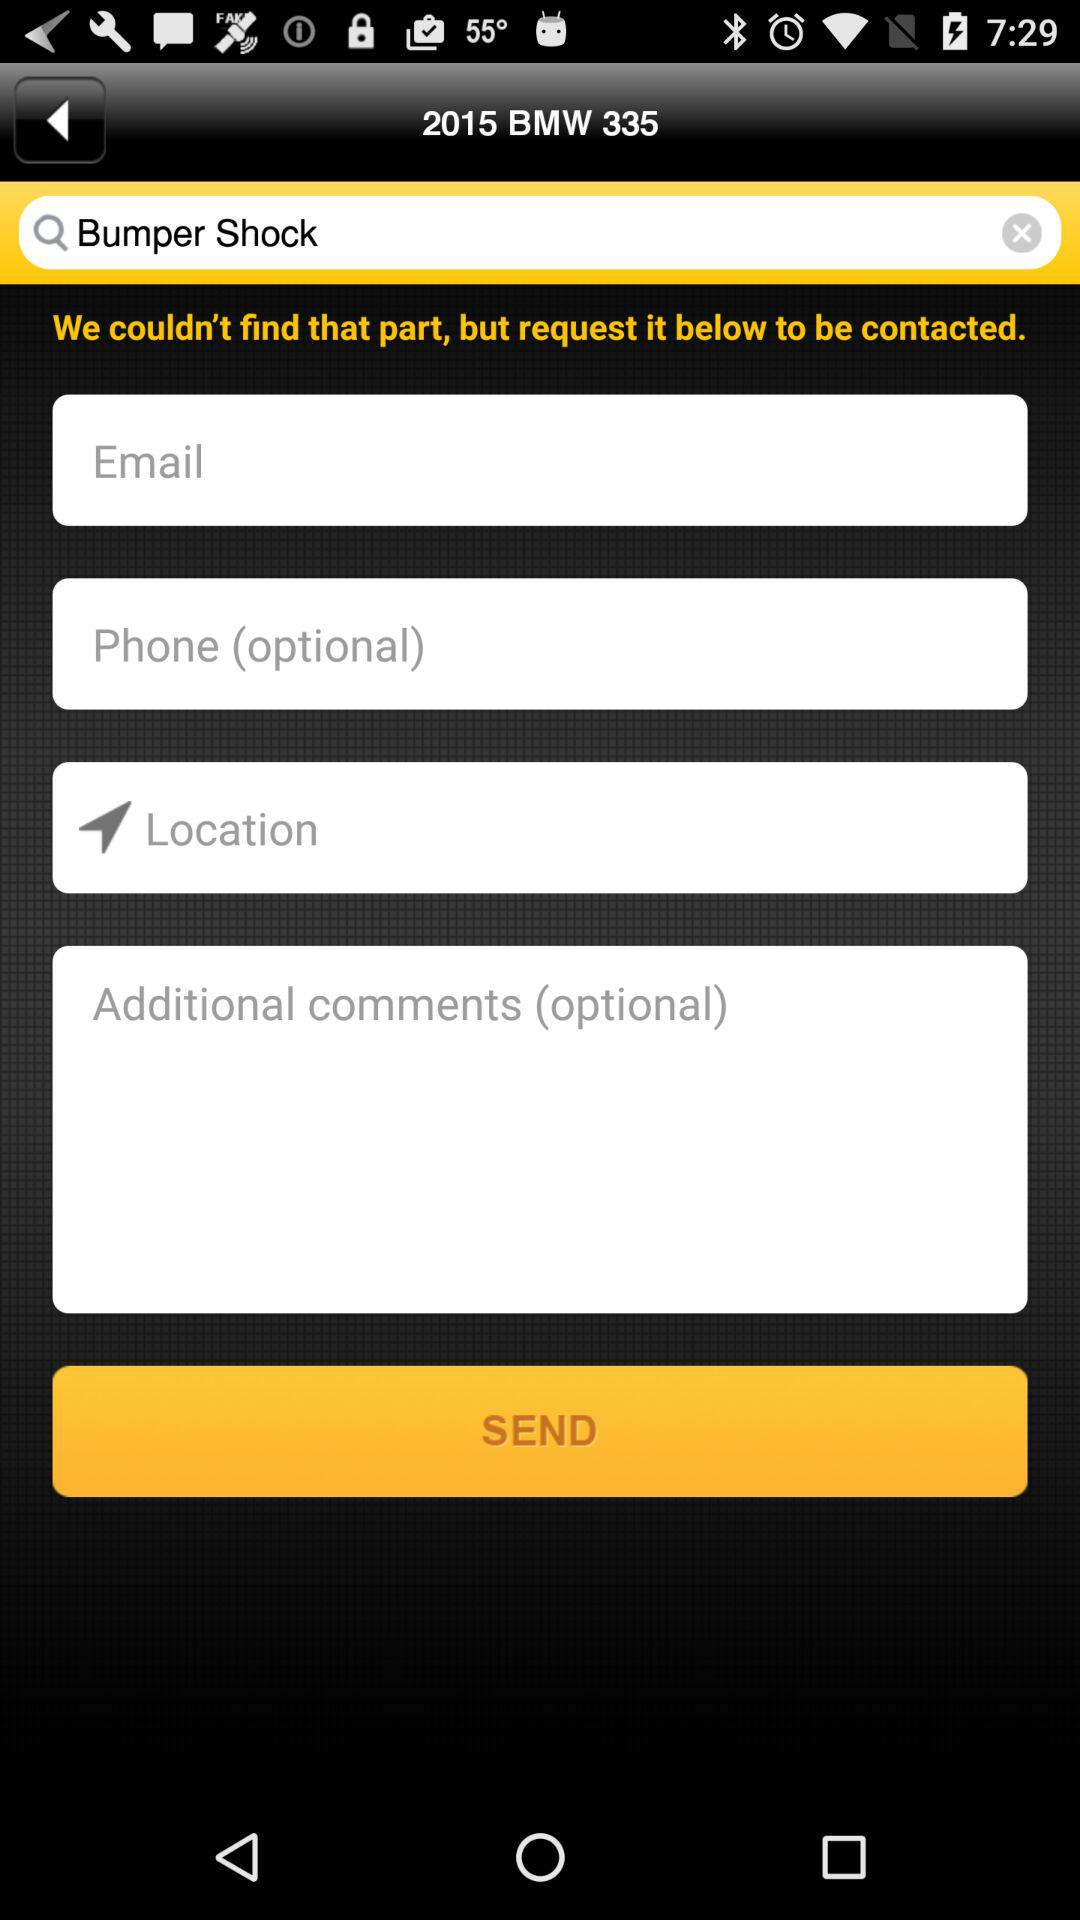How many of the input fields are optional?
Answer the question using a single word or phrase. 2 